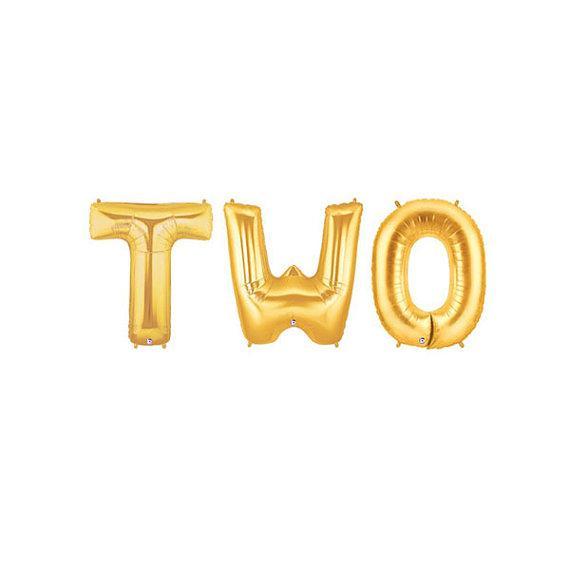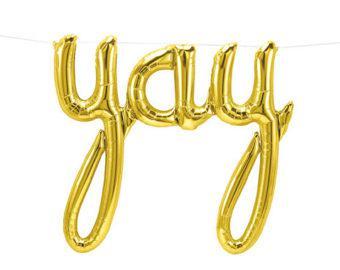The first image is the image on the left, the second image is the image on the right. Assess this claim about the two images: "One of the balloons is shaped like the number 2.". Correct or not? Answer yes or no. No. The first image is the image on the left, the second image is the image on the right. Evaluate the accuracy of this statement regarding the images: "One image shows a balloon shaped like the number 2, along with other balloons.". Is it true? Answer yes or no. No. 